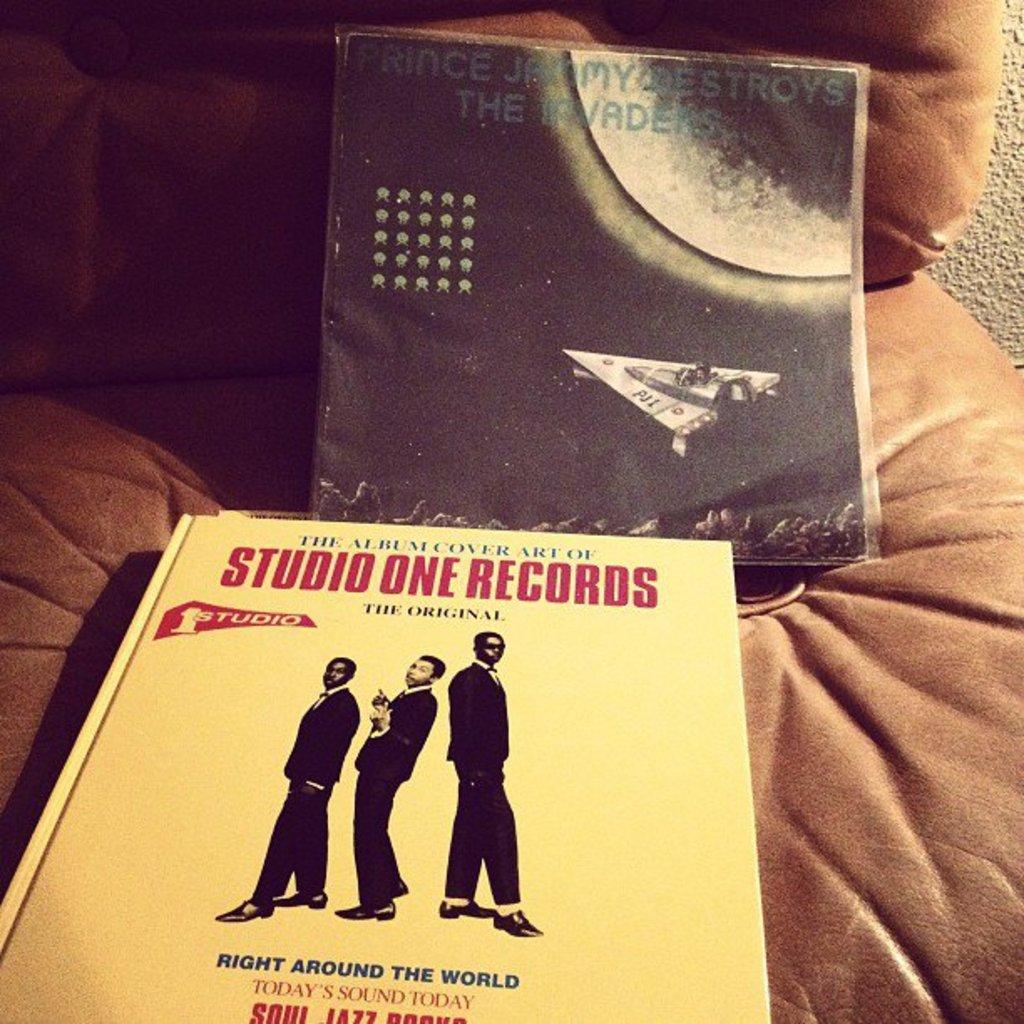What is written on the album cover?
Make the answer very short. Prince jammy destroys the invaders. 